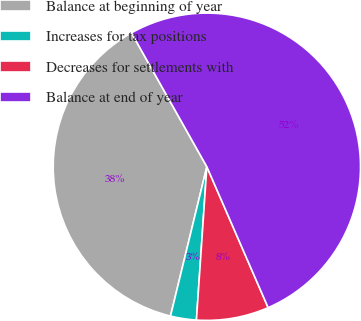Convert chart to OTSL. <chart><loc_0><loc_0><loc_500><loc_500><pie_chart><fcel>Balance at beginning of year<fcel>Increases for tax positions<fcel>Decreases for settlements with<fcel>Balance at end of year<nl><fcel>38.04%<fcel>2.72%<fcel>7.61%<fcel>51.63%<nl></chart> 